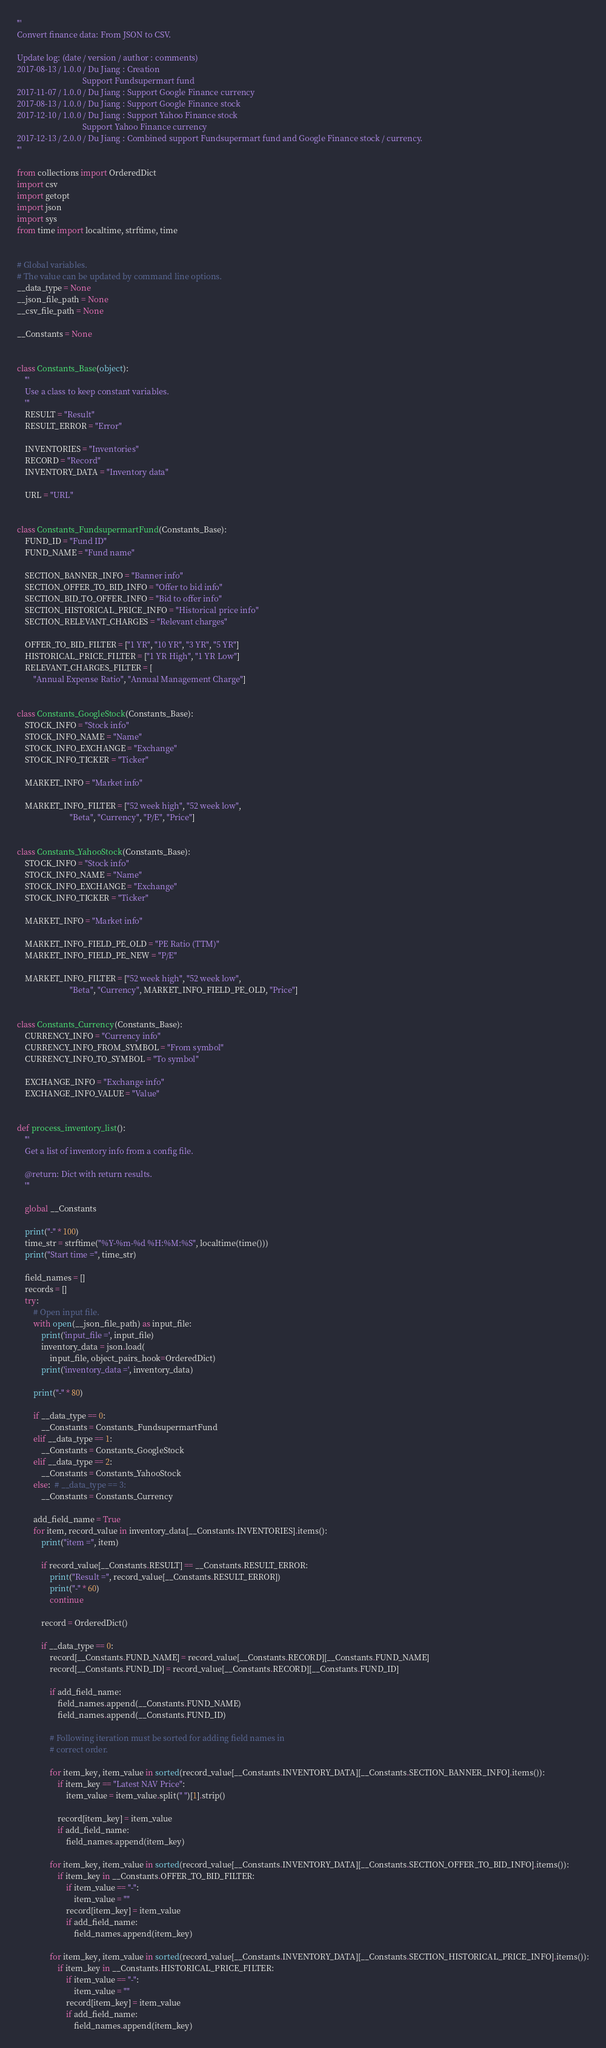<code> <loc_0><loc_0><loc_500><loc_500><_Python_>'''
Convert finance data: From JSON to CSV.

Update log: (date / version / author : comments)
2017-08-13 / 1.0.0 / Du Jiang : Creation
                                Support Fundsupermart fund
2017-11-07 / 1.0.0 / Du Jiang : Support Google Finance currency
2017-08-13 / 1.0.0 / Du Jiang : Support Google Finance stock
2017-12-10 / 1.0.0 / Du Jiang : Support Yahoo Finance stock
                                Support Yahoo Finance currency
2017-12-13 / 2.0.0 / Du Jiang : Combined support Fundsupermart fund and Google Finance stock / currency.
'''

from collections import OrderedDict
import csv
import getopt
import json
import sys
from time import localtime, strftime, time


# Global variables.
# The value can be updated by command line options.
__data_type = None
__json_file_path = None
__csv_file_path = None

__Constants = None


class Constants_Base(object):
    '''
    Use a class to keep constant variables.
    '''
    RESULT = "Result"
    RESULT_ERROR = "Error"

    INVENTORIES = "Inventories"
    RECORD = "Record"
    INVENTORY_DATA = "Inventory data"

    URL = "URL"


class Constants_FundsupermartFund(Constants_Base):
    FUND_ID = "Fund ID"
    FUND_NAME = "Fund name"

    SECTION_BANNER_INFO = "Banner info"
    SECTION_OFFER_TO_BID_INFO = "Offer to bid info"
    SECTION_BID_TO_OFFER_INFO = "Bid to offer info"
    SECTION_HISTORICAL_PRICE_INFO = "Historical price info"
    SECTION_RELEVANT_CHARGES = "Relevant charges"

    OFFER_TO_BID_FILTER = ["1 YR", "10 YR", "3 YR", "5 YR"]
    HISTORICAL_PRICE_FILTER = ["1 YR High", "1 YR Low"]
    RELEVANT_CHARGES_FILTER = [
        "Annual Expense Ratio", "Annual Management Charge"]


class Constants_GoogleStock(Constants_Base):
    STOCK_INFO = "Stock info"
    STOCK_INFO_NAME = "Name"
    STOCK_INFO_EXCHANGE = "Exchange"
    STOCK_INFO_TICKER = "Ticker"

    MARKET_INFO = "Market info"

    MARKET_INFO_FILTER = ["52 week high", "52 week low",
                          "Beta", "Currency", "P/E", "Price"]


class Constants_YahooStock(Constants_Base):
    STOCK_INFO = "Stock info"
    STOCK_INFO_NAME = "Name"
    STOCK_INFO_EXCHANGE = "Exchange"
    STOCK_INFO_TICKER = "Ticker"

    MARKET_INFO = "Market info"

    MARKET_INFO_FIELD_PE_OLD = "PE Ratio (TTM)"
    MARKET_INFO_FIELD_PE_NEW = "P/E"

    MARKET_INFO_FILTER = ["52 week high", "52 week low",
                          "Beta", "Currency", MARKET_INFO_FIELD_PE_OLD, "Price"]


class Constants_Currency(Constants_Base):
    CURRENCY_INFO = "Currency info"
    CURRENCY_INFO_FROM_SYMBOL = "From symbol"
    CURRENCY_INFO_TO_SYMBOL = "To symbol"

    EXCHANGE_INFO = "Exchange info"
    EXCHANGE_INFO_VALUE = "Value"


def process_inventory_list():
    '''
    Get a list of inventory info from a config file.

    @return: Dict with return results.
    '''

    global __Constants

    print("-" * 100)
    time_str = strftime("%Y-%m-%d %H:%M:%S", localtime(time()))
    print("Start time =", time_str)

    field_names = []
    records = []
    try:
        # Open input file.
        with open(__json_file_path) as input_file:
            print('input_file =', input_file)
            inventory_data = json.load(
                input_file, object_pairs_hook=OrderedDict)
            print('inventory_data =', inventory_data)

        print("-" * 80)

        if __data_type == 0:
            __Constants = Constants_FundsupermartFund
        elif __data_type == 1:
            __Constants = Constants_GoogleStock
        elif __data_type == 2:
            __Constants = Constants_YahooStock
        else:  # __data_type == 3:
            __Constants = Constants_Currency

        add_field_name = True
        for item, record_value in inventory_data[__Constants.INVENTORIES].items():
            print("item =", item)

            if record_value[__Constants.RESULT] == __Constants.RESULT_ERROR:
                print("Result =", record_value[__Constants.RESULT_ERROR])
                print("-" * 60)
                continue

            record = OrderedDict()

            if __data_type == 0:
                record[__Constants.FUND_NAME] = record_value[__Constants.RECORD][__Constants.FUND_NAME]
                record[__Constants.FUND_ID] = record_value[__Constants.RECORD][__Constants.FUND_ID]

                if add_field_name:
                    field_names.append(__Constants.FUND_NAME)
                    field_names.append(__Constants.FUND_ID)

                # Following iteration must be sorted for adding field names in
                # correct order.

                for item_key, item_value in sorted(record_value[__Constants.INVENTORY_DATA][__Constants.SECTION_BANNER_INFO].items()):
                    if item_key == "Latest NAV Price":
                        item_value = item_value.split(" ")[1].strip()

                    record[item_key] = item_value
                    if add_field_name:
                        field_names.append(item_key)

                for item_key, item_value in sorted(record_value[__Constants.INVENTORY_DATA][__Constants.SECTION_OFFER_TO_BID_INFO].items()):
                    if item_key in __Constants.OFFER_TO_BID_FILTER:
                        if item_value == "-":
                            item_value = ""
                        record[item_key] = item_value
                        if add_field_name:
                            field_names.append(item_key)

                for item_key, item_value in sorted(record_value[__Constants.INVENTORY_DATA][__Constants.SECTION_HISTORICAL_PRICE_INFO].items()):
                    if item_key in __Constants.HISTORICAL_PRICE_FILTER:
                        if item_value == "-":
                            item_value = ""
                        record[item_key] = item_value
                        if add_field_name:
                            field_names.append(item_key)
</code> 